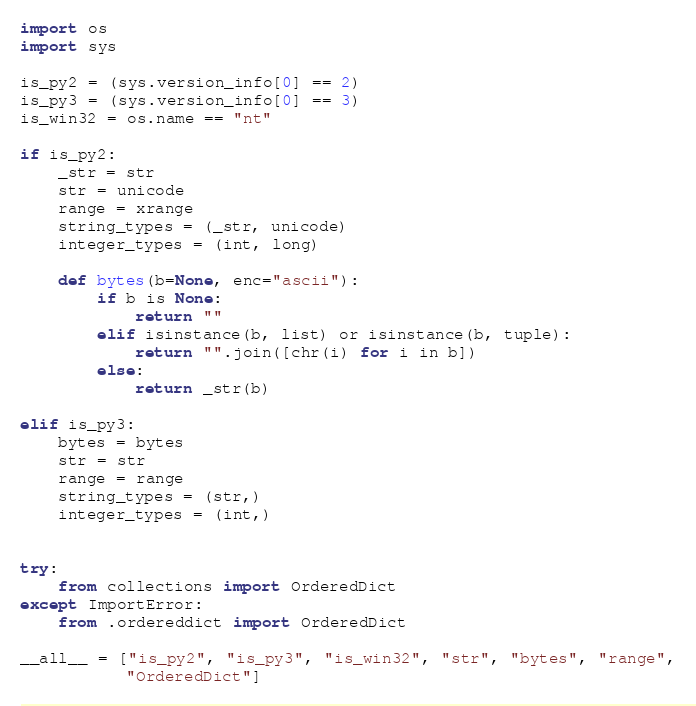<code> <loc_0><loc_0><loc_500><loc_500><_Python_>import os
import sys

is_py2 = (sys.version_info[0] == 2)
is_py3 = (sys.version_info[0] == 3)
is_win32 = os.name == "nt"

if is_py2:
    _str = str
    str = unicode
    range = xrange
    string_types = (_str, unicode)
    integer_types = (int, long)

    def bytes(b=None, enc="ascii"):
        if b is None:
            return ""
        elif isinstance(b, list) or isinstance(b, tuple):
            return "".join([chr(i) for i in b])
        else:
            return _str(b)

elif is_py3:
    bytes = bytes
    str = str
    range = range
    string_types = (str,)
    integer_types = (int,)


try:
    from collections import OrderedDict
except ImportError:
    from .ordereddict import OrderedDict

__all__ = ["is_py2", "is_py3", "is_win32", "str", "bytes", "range",
           "OrderedDict"]
</code> 